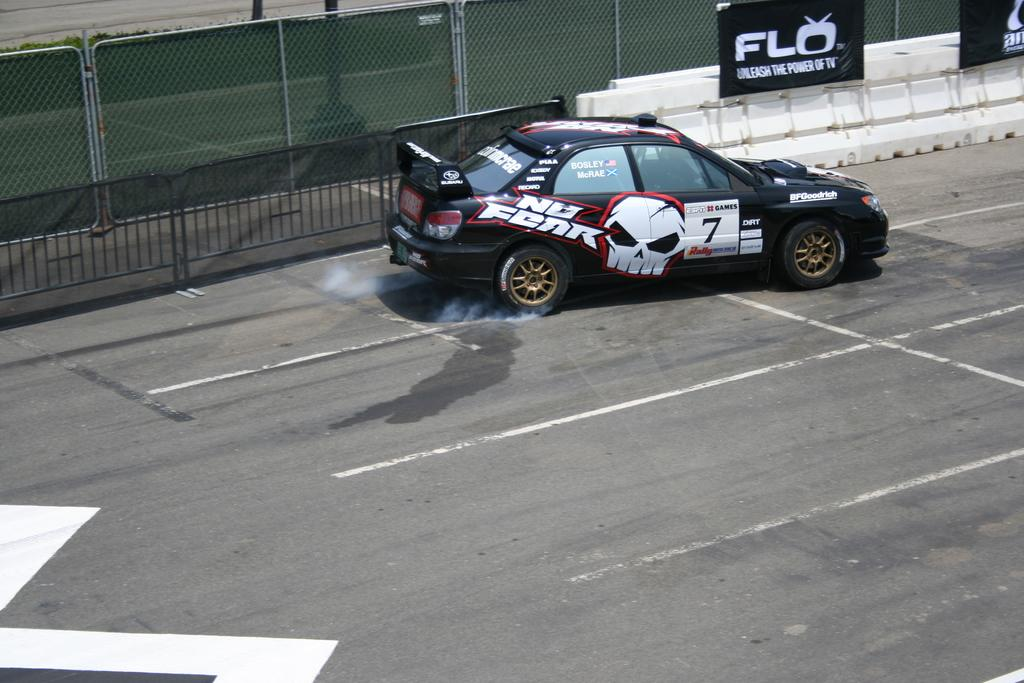What type of vehicle is in the image? There is a sports car in the image. What can be seen around the sports car? There is a boundary in the image. What is located at the top side of the image? There is a poster at the top side of the image. What type of silverware is visible on the sports car in the image? There is no silverware present on the sports car in the image. Can you see any airplanes or airport-related objects in the image? There are no airplanes or airport-related objects present in the image. 